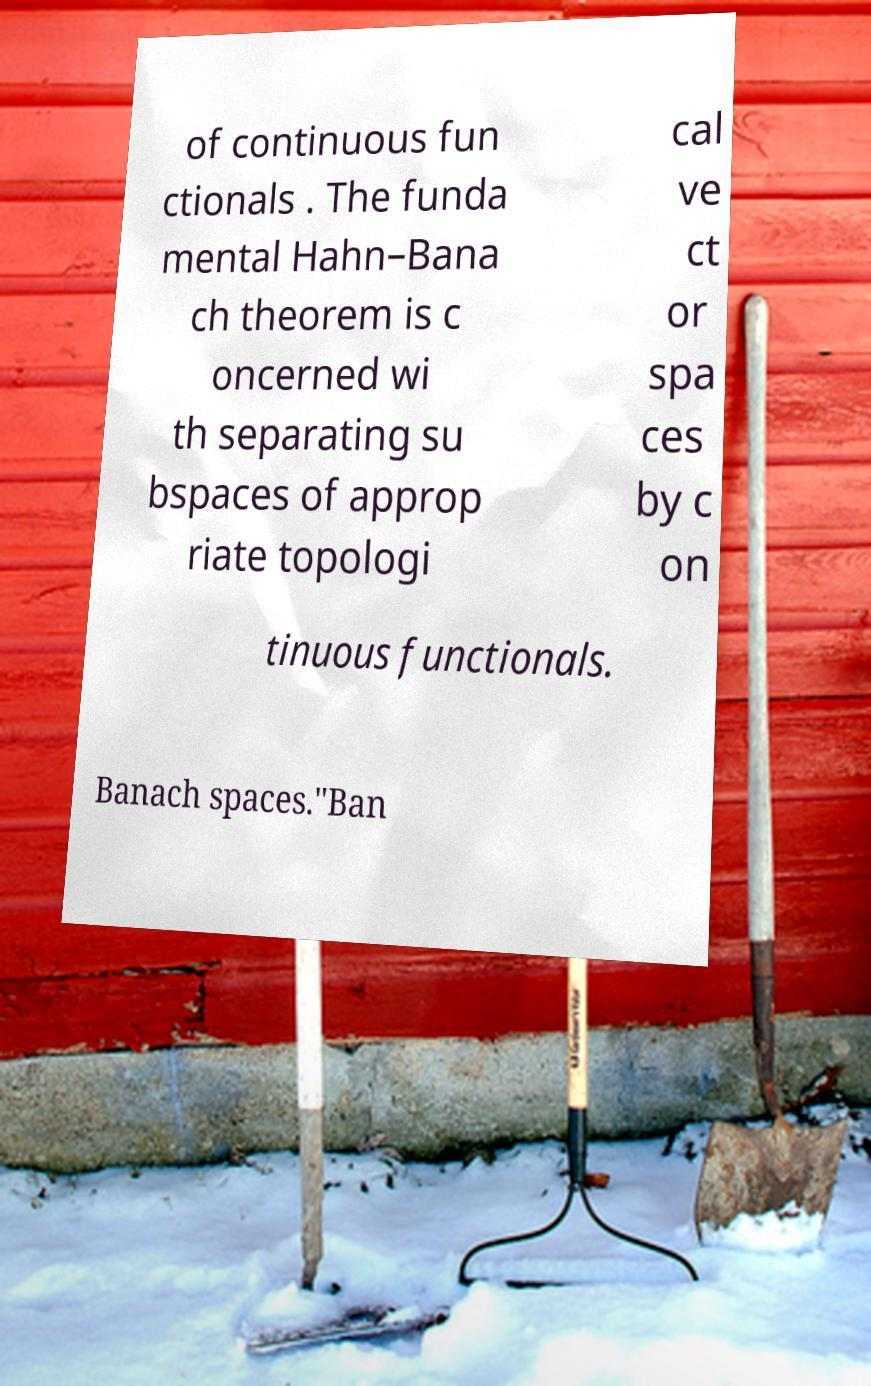Could you assist in decoding the text presented in this image and type it out clearly? of continuous fun ctionals . The funda mental Hahn–Bana ch theorem is c oncerned wi th separating su bspaces of approp riate topologi cal ve ct or spa ces by c on tinuous functionals. Banach spaces."Ban 